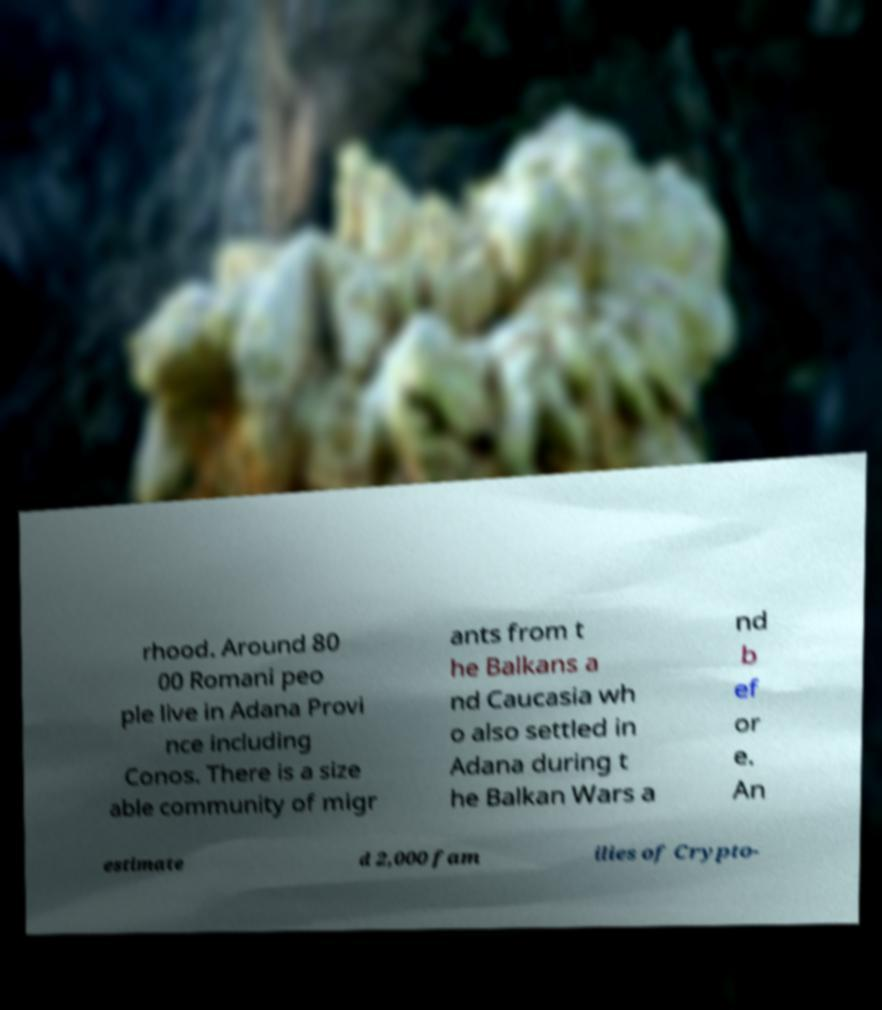I need the written content from this picture converted into text. Can you do that? rhood. Around 80 00 Romani peo ple live in Adana Provi nce including Conos. There is a size able community of migr ants from t he Balkans a nd Caucasia wh o also settled in Adana during t he Balkan Wars a nd b ef or e. An estimate d 2,000 fam ilies of Crypto- 